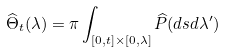Convert formula to latex. <formula><loc_0><loc_0><loc_500><loc_500>\widehat { \Theta } _ { t } ( \lambda ) = \pi \int _ { [ 0 , t ] \times [ 0 , \lambda ] } \widehat { P } ( d s d \lambda ^ { \prime } )</formula> 